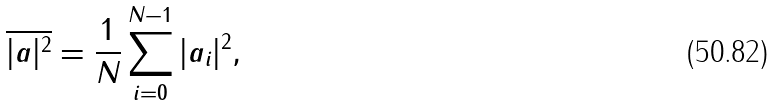<formula> <loc_0><loc_0><loc_500><loc_500>\overline { | a | ^ { 2 } } = { \frac { 1 } { N } } \sum _ { i = 0 } ^ { N - 1 } | a _ { i } | ^ { 2 } ,</formula> 